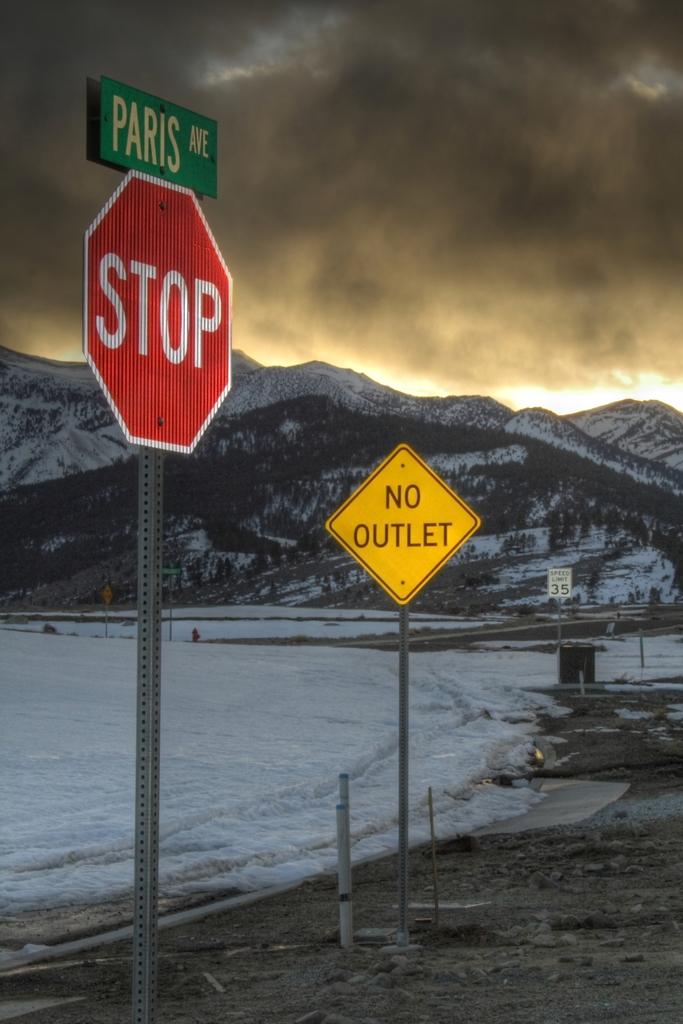What avenue is this?
Keep it short and to the point. Paris. What does the yellow sign say?
Offer a terse response. No outlet. 